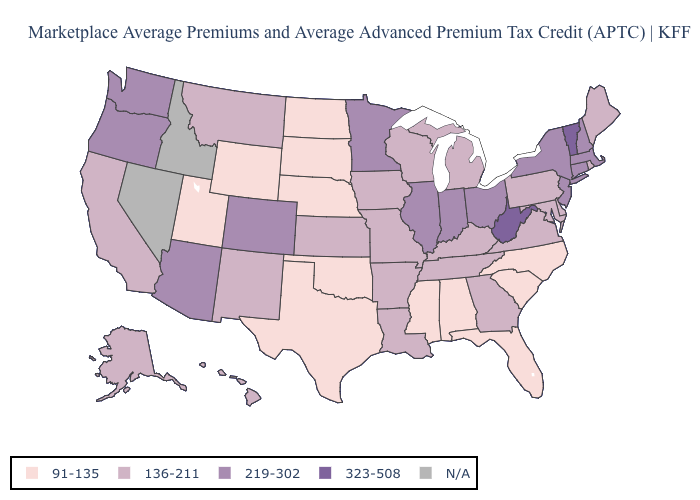Does Maine have the lowest value in the Northeast?
Keep it brief. Yes. Which states have the lowest value in the USA?
Short answer required. Alabama, Florida, Mississippi, Nebraska, North Carolina, North Dakota, Oklahoma, South Carolina, South Dakota, Texas, Utah, Wyoming. Name the states that have a value in the range 91-135?
Short answer required. Alabama, Florida, Mississippi, Nebraska, North Carolina, North Dakota, Oklahoma, South Carolina, South Dakota, Texas, Utah, Wyoming. Name the states that have a value in the range 323-508?
Concise answer only. Vermont, West Virginia. What is the lowest value in states that border Michigan?
Keep it brief. 136-211. What is the value of Ohio?
Write a very short answer. 219-302. Among the states that border Wyoming , which have the highest value?
Answer briefly. Colorado. Name the states that have a value in the range N/A?
Answer briefly. Idaho, Nevada. Does Arkansas have the lowest value in the South?
Short answer required. No. Name the states that have a value in the range 91-135?
Quick response, please. Alabama, Florida, Mississippi, Nebraska, North Carolina, North Dakota, Oklahoma, South Carolina, South Dakota, Texas, Utah, Wyoming. Name the states that have a value in the range N/A?
Concise answer only. Idaho, Nevada. Name the states that have a value in the range 136-211?
Give a very brief answer. Alaska, Arkansas, California, Delaware, Georgia, Hawaii, Iowa, Kansas, Kentucky, Louisiana, Maine, Maryland, Michigan, Missouri, Montana, New Mexico, Pennsylvania, Rhode Island, Tennessee, Virginia, Wisconsin. Does Missouri have the highest value in the USA?
Short answer required. No. Does Indiana have the highest value in the MidWest?
Short answer required. Yes. Among the states that border South Carolina , which have the highest value?
Write a very short answer. Georgia. 